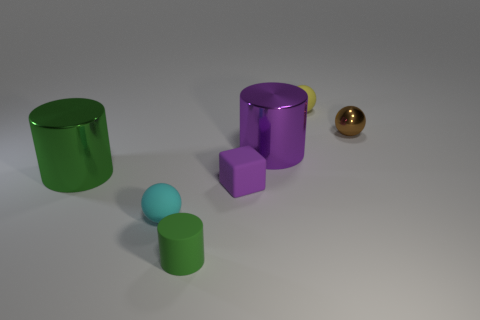Add 3 small yellow objects. How many objects exist? 10 Subtract all balls. How many objects are left? 4 Subtract all small green shiny objects. Subtract all purple blocks. How many objects are left? 6 Add 2 big purple cylinders. How many big purple cylinders are left? 3 Add 5 tiny yellow matte cylinders. How many tiny yellow matte cylinders exist? 5 Subtract 1 yellow balls. How many objects are left? 6 